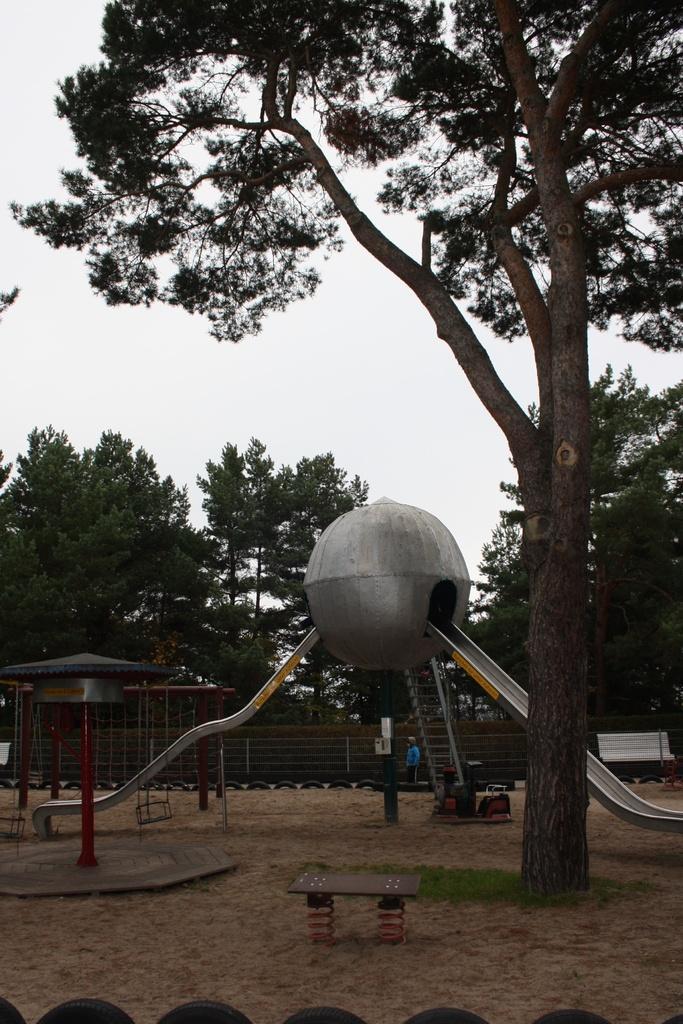How would you summarize this image in a sentence or two? This image is taken outdoors. At the top of the image there is the sky. In the background there are many trees with stems, branches and green leaves. At the bottom of the image there is a fence and there is a ground with grass on it. In the middle of the image there are a few slides and stairs. There are a few iron bars. There is an empty bench and a man is standing on the ground. There is a railing. 